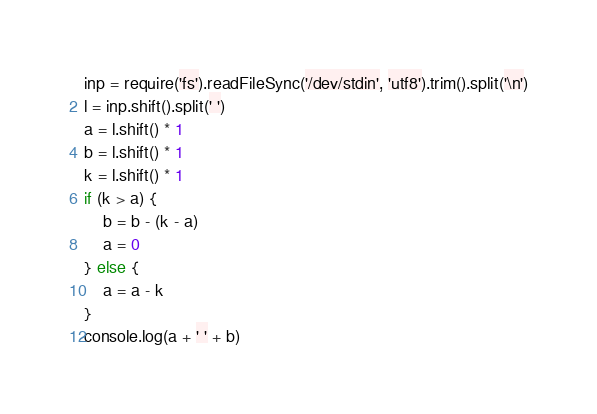<code> <loc_0><loc_0><loc_500><loc_500><_JavaScript_>inp = require('fs').readFileSync('/dev/stdin', 'utf8').trim().split('\n')
l = inp.shift().split(' ')
a = l.shift() * 1
b = l.shift() * 1
k = l.shift() * 1
if (k > a) {
    b = b - (k - a)
    a = 0
} else {
    a = a - k
}
console.log(a + ' ' + b)
</code> 